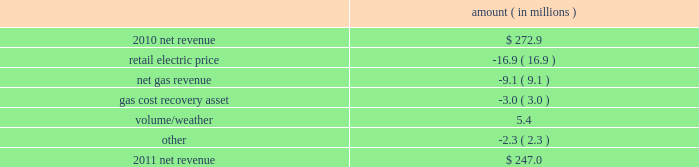Entergy new orleans , inc .
Management 2019s financial discussion and analysis plan to spin off the utility 2019s transmission business see the 201cplan to spin off the utility 2019s transmission business 201d section of entergy corporation and subsidiaries management 2019s financial discussion and analysis for a discussion of this matter , including the planned retirement of debt and preferred securities .
Results of operations net income 2011 compared to 2010 net income increased $ 4.9 million primarily due to lower other operation and maintenance expenses , lower taxes other than income taxes , a lower effective income tax rate , and lower interest expense , partially offset by lower net revenue .
2010 compared to 2009 net income remained relatively unchanged , increasing $ 0.6 million , primarily due to higher net revenue and lower interest expense , almost entirely offset by higher other operation and maintenance expenses , higher taxes other than income taxes , lower other income , and higher depreciation and amortization expenses .
Net revenue 2011 compared to 2010 net revenue consists of operating revenues net of : 1 ) fuel , fuel-related expenses , and gas purchased for resale , 2 ) purchased power expenses , and 3 ) other regulatory charges ( credits ) .
Following is an analysis of the change in net revenue comparing 2011 to 2010 .
Amount ( in millions ) .
The retail electric price variance is primarily due to formula rate plan decreases effective october 2010 and october 2011 .
See note 2 to the financial statements for a discussion of the formula rate plan filing .
The net gas revenue variance is primarily due to milder weather in 2011 compared to 2010 .
The gas cost recovery asset variance is primarily due to the recognition in 2010 of a $ 3 million gas operations regulatory asset associated with the settlement of entergy new orleans 2019s electric and gas formula rate plan case and the amortization of that asset .
See note 2 to the financial statements for additional discussion of the formula rate plan settlement. .
From the change in net revenue in 2011 , what percentage is attributed to change in retail electric price? 
Computations: (-16.9 / (247.0 - 272.9))
Answer: 0.65251. 